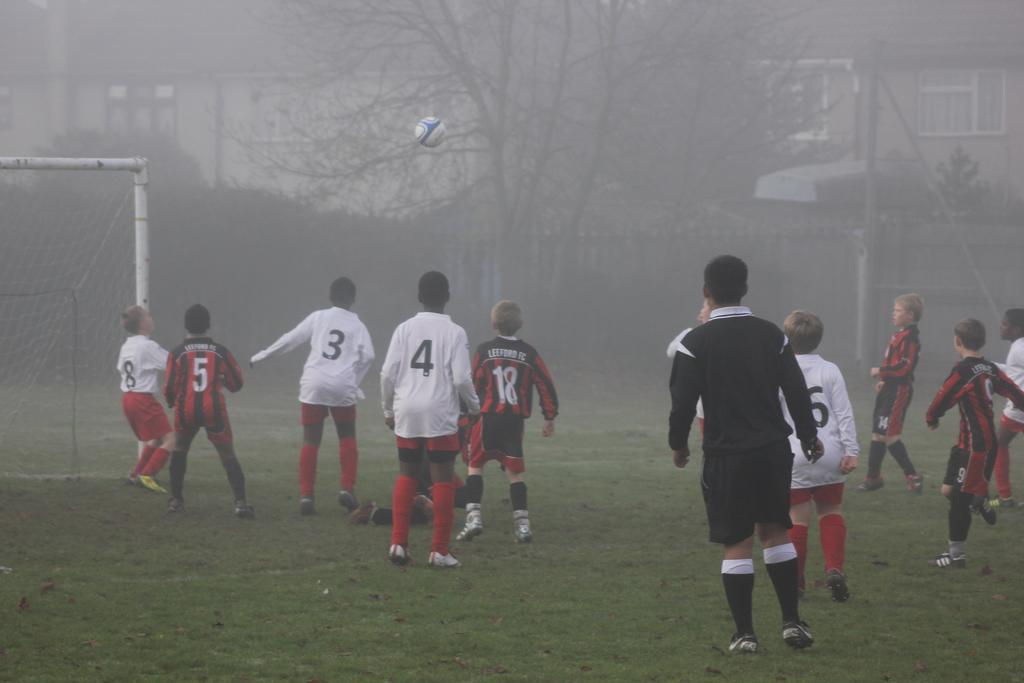<image>
Provide a brief description of the given image. boys playing soccer in the fog the team in red stripes is leeford fc 